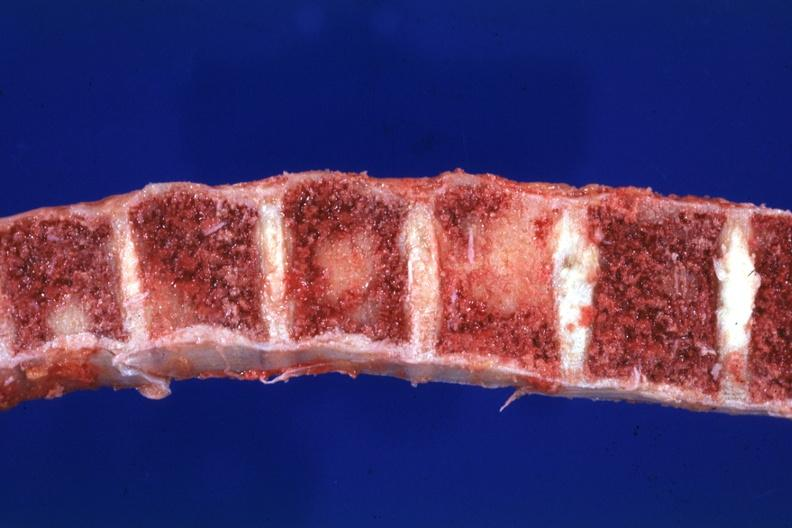s joints present?
Answer the question using a single word or phrase. Yes 